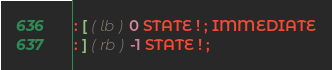Convert code to text. <code><loc_0><loc_0><loc_500><loc_500><_Forth_>: [ ( lb ) 0 STATE ! ; IMMEDIATE
: ] ( rb ) -1 STATE ! ;
</code> 